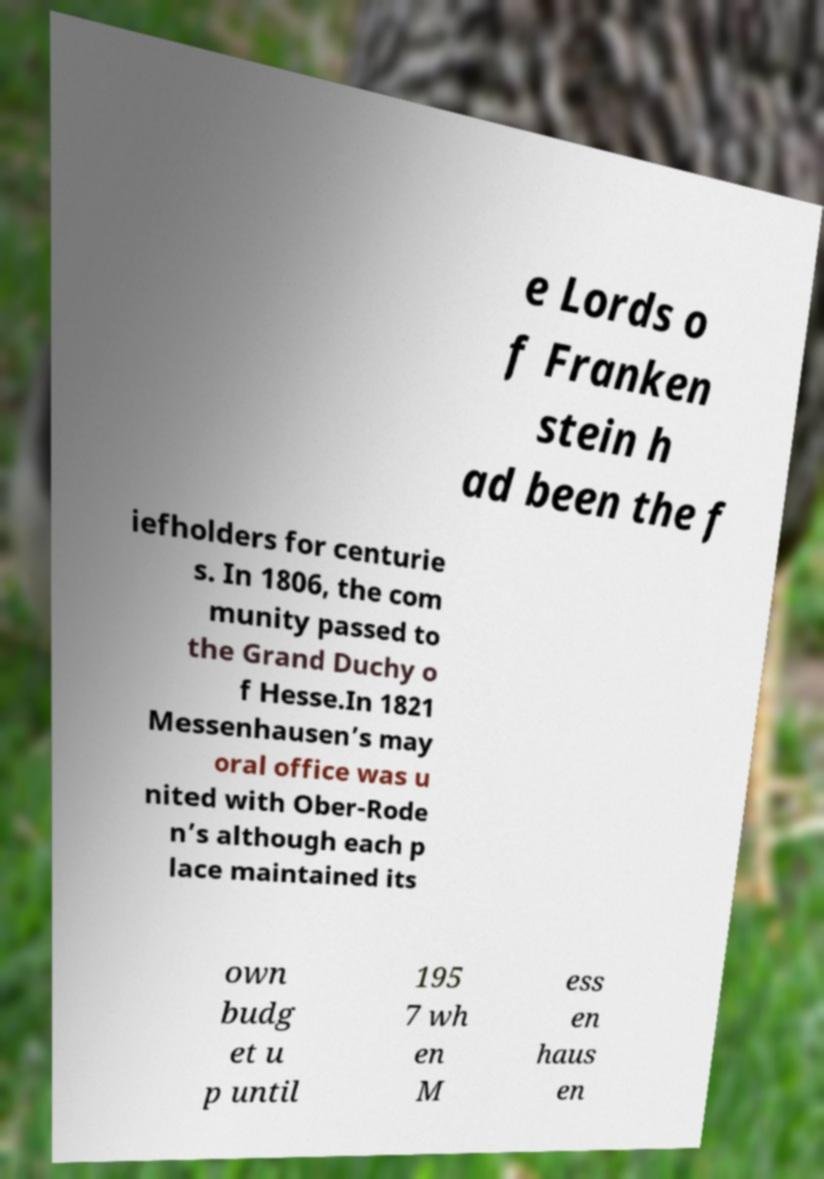Please identify and transcribe the text found in this image. e Lords o f Franken stein h ad been the f iefholders for centurie s. In 1806, the com munity passed to the Grand Duchy o f Hesse.In 1821 Messenhausen’s may oral office was u nited with Ober-Rode n’s although each p lace maintained its own budg et u p until 195 7 wh en M ess en haus en 